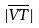<formula> <loc_0><loc_0><loc_500><loc_500>| \overline { V T } |</formula> 